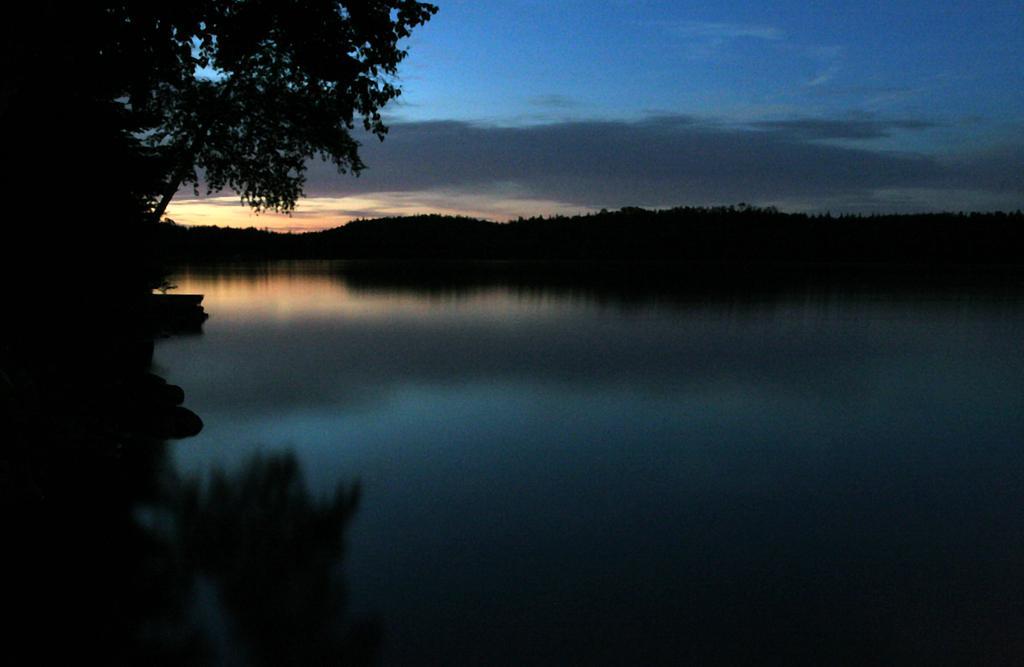What is the primary element visible in the image? There is water in the image. What can be seen in the foreground of the image? There is a tree in the front of the image. What is visible in the background of the image? There are multiple trees and clouds visible in the background of the image. What part of the natural environment is visible in the image? The sky is visible in the background of the image. What type of honey can be seen dripping from the tree in the image? There is no honey present in the image; it features water and trees. Can you tell me how the hospital is blowing in the wind in the image? There is no hospital present in the image, and therefore no blowing can be observed. 